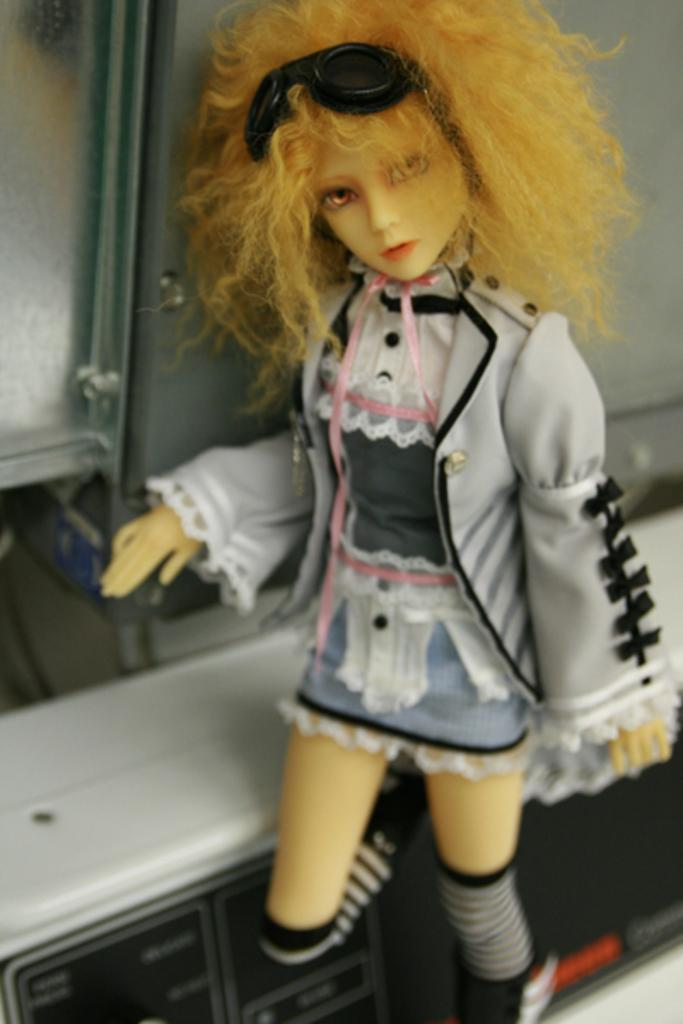What object can be seen in the image? There is a toy in the image. Where is the toy positioned in relation to the image? The toy is standing in the front. What type of nail is being used to hold the toy in place in the image? There is no nail present in the image, and the toy is not being held in place. 